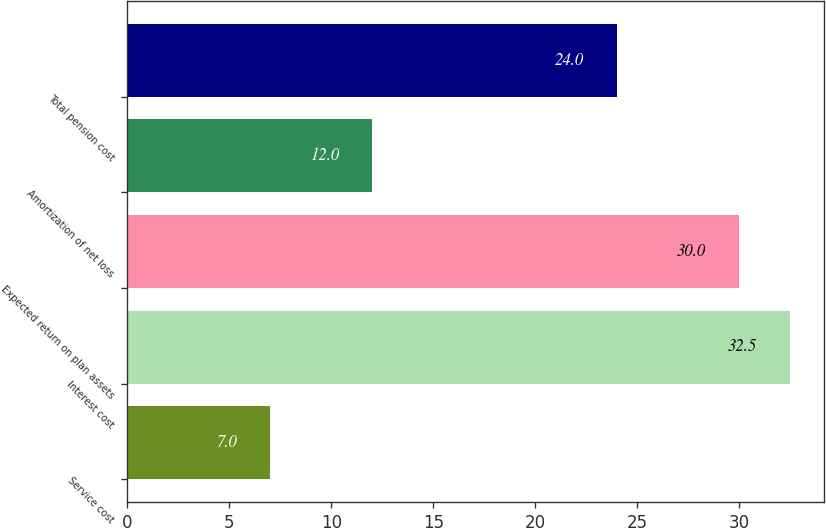<chart> <loc_0><loc_0><loc_500><loc_500><bar_chart><fcel>Service cost<fcel>Interest cost<fcel>Expected return on plan assets<fcel>Amortization of net loss<fcel>Total pension cost<nl><fcel>7<fcel>32.5<fcel>30<fcel>12<fcel>24<nl></chart> 